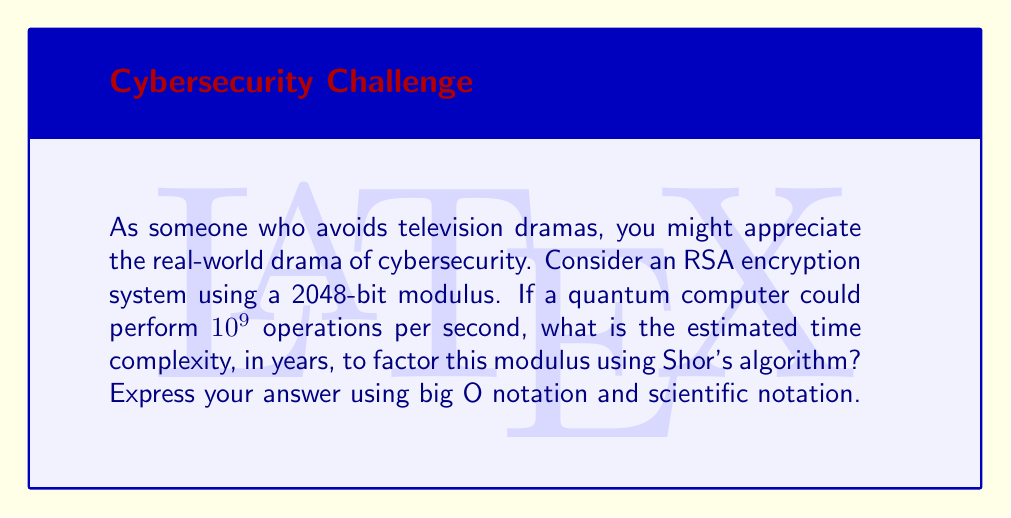Can you solve this math problem? Let's approach this step-by-step:

1) RSA encryption relies on the difficulty of factoring large numbers. The time complexity of factoring using classical algorithms is sub-exponential:

   $$O(e^{(\sqrt[3]{\frac{64}{9}n(\ln n)^2})^{\frac{1}{3}}})$$

   where $n$ is the number of bits in the modulus.

2) However, Shor's quantum algorithm has a time complexity of:

   $$O(((\log N)^2(\log \log N))(\log \log \log N))$$

   where $N$ is the number to be factored.

3) For a 2048-bit modulus, $N \approx 2^{2048}$, so $\log N \approx 2048$.

4) Substituting this into Shor's algorithm complexity:

   $$O((2048^2(\log 2048))(\log \log 2048))$$

5) Simplifying:
   $$O((2048^2 \cdot 11)(4)) \approx O(2^{23})$$

6) If the quantum computer can perform $10^9$ operations per second, the time to factor would be approximately:

   $$\frac{2^{23}}{10^9} \approx 8.4 \text{ seconds}$$

7) Converting to years and using scientific notation:

   $$8.4 \text{ seconds} \approx 2.66 \times 10^{-7} \text{ years}$$
Answer: $O(2^{23})$ operations, or $2.66 \times 10^{-7}$ years 